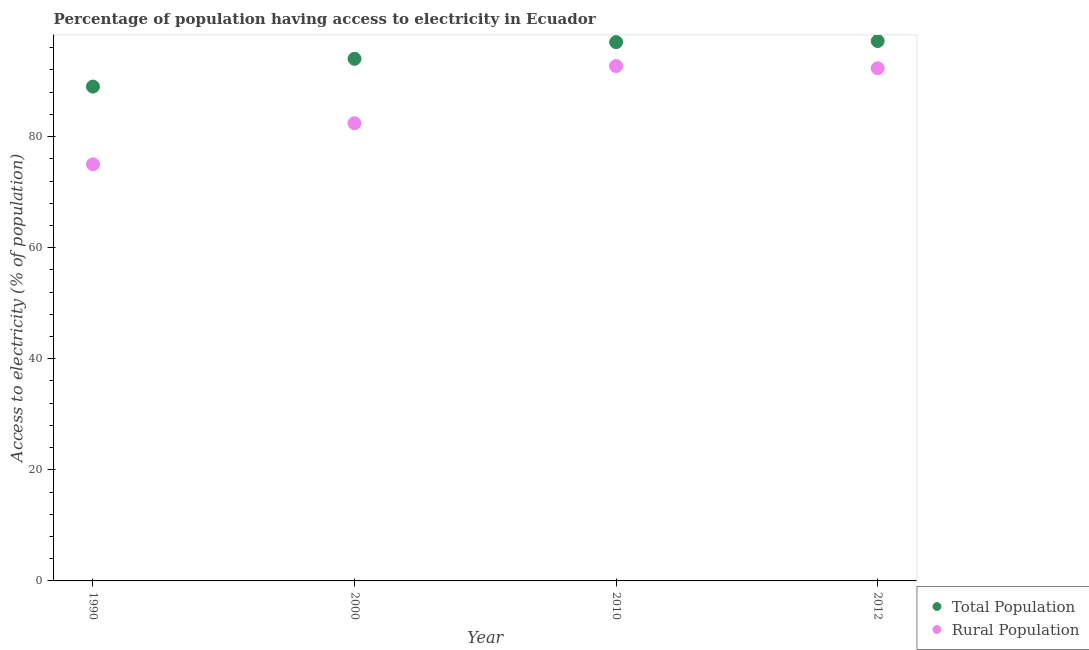Is the number of dotlines equal to the number of legend labels?
Ensure brevity in your answer.  Yes. What is the percentage of population having access to electricity in 2010?
Keep it short and to the point. 97. Across all years, what is the maximum percentage of population having access to electricity?
Give a very brief answer. 97.2. Across all years, what is the minimum percentage of rural population having access to electricity?
Provide a succinct answer. 75. In which year was the percentage of population having access to electricity minimum?
Offer a very short reply. 1990. What is the total percentage of population having access to electricity in the graph?
Keep it short and to the point. 377.2. What is the difference between the percentage of rural population having access to electricity in 2000 and that in 2012?
Keep it short and to the point. -9.9. What is the difference between the percentage of rural population having access to electricity in 2010 and the percentage of population having access to electricity in 2000?
Your response must be concise. -1.3. What is the average percentage of rural population having access to electricity per year?
Your answer should be compact. 85.6. In the year 1990, what is the difference between the percentage of rural population having access to electricity and percentage of population having access to electricity?
Ensure brevity in your answer.  -14. What is the ratio of the percentage of population having access to electricity in 2000 to that in 2012?
Provide a short and direct response. 0.97. Is the percentage of population having access to electricity in 2000 less than that in 2012?
Offer a very short reply. Yes. Is the difference between the percentage of population having access to electricity in 1990 and 2012 greater than the difference between the percentage of rural population having access to electricity in 1990 and 2012?
Your answer should be very brief. Yes. What is the difference between the highest and the second highest percentage of population having access to electricity?
Your answer should be very brief. 0.2. What is the difference between the highest and the lowest percentage of population having access to electricity?
Make the answer very short. 8.2. In how many years, is the percentage of rural population having access to electricity greater than the average percentage of rural population having access to electricity taken over all years?
Ensure brevity in your answer.  2. How many dotlines are there?
Make the answer very short. 2. How many years are there in the graph?
Provide a short and direct response. 4. Are the values on the major ticks of Y-axis written in scientific E-notation?
Offer a very short reply. No. Does the graph contain grids?
Give a very brief answer. No. How are the legend labels stacked?
Provide a succinct answer. Vertical. What is the title of the graph?
Give a very brief answer. Percentage of population having access to electricity in Ecuador. What is the label or title of the Y-axis?
Provide a succinct answer. Access to electricity (% of population). What is the Access to electricity (% of population) of Total Population in 1990?
Your answer should be compact. 89. What is the Access to electricity (% of population) of Total Population in 2000?
Provide a succinct answer. 94. What is the Access to electricity (% of population) of Rural Population in 2000?
Offer a terse response. 82.4. What is the Access to electricity (% of population) of Total Population in 2010?
Provide a succinct answer. 97. What is the Access to electricity (% of population) of Rural Population in 2010?
Give a very brief answer. 92.7. What is the Access to electricity (% of population) of Total Population in 2012?
Your answer should be very brief. 97.2. What is the Access to electricity (% of population) of Rural Population in 2012?
Provide a succinct answer. 92.3. Across all years, what is the maximum Access to electricity (% of population) in Total Population?
Ensure brevity in your answer.  97.2. Across all years, what is the maximum Access to electricity (% of population) in Rural Population?
Provide a succinct answer. 92.7. Across all years, what is the minimum Access to electricity (% of population) of Total Population?
Provide a succinct answer. 89. Across all years, what is the minimum Access to electricity (% of population) in Rural Population?
Give a very brief answer. 75. What is the total Access to electricity (% of population) in Total Population in the graph?
Keep it short and to the point. 377.2. What is the total Access to electricity (% of population) of Rural Population in the graph?
Ensure brevity in your answer.  342.4. What is the difference between the Access to electricity (% of population) of Rural Population in 1990 and that in 2010?
Give a very brief answer. -17.7. What is the difference between the Access to electricity (% of population) of Rural Population in 1990 and that in 2012?
Give a very brief answer. -17.3. What is the difference between the Access to electricity (% of population) of Total Population in 2000 and that in 2012?
Your answer should be compact. -3.2. What is the difference between the Access to electricity (% of population) in Rural Population in 2000 and that in 2012?
Ensure brevity in your answer.  -9.9. What is the difference between the Access to electricity (% of population) of Total Population in 2010 and that in 2012?
Offer a terse response. -0.2. What is the difference between the Access to electricity (% of population) of Rural Population in 2010 and that in 2012?
Your answer should be compact. 0.4. What is the difference between the Access to electricity (% of population) of Total Population in 1990 and the Access to electricity (% of population) of Rural Population in 2000?
Your answer should be very brief. 6.6. What is the difference between the Access to electricity (% of population) of Total Population in 2000 and the Access to electricity (% of population) of Rural Population in 2012?
Offer a very short reply. 1.7. What is the difference between the Access to electricity (% of population) of Total Population in 2010 and the Access to electricity (% of population) of Rural Population in 2012?
Keep it short and to the point. 4.7. What is the average Access to electricity (% of population) of Total Population per year?
Your response must be concise. 94.3. What is the average Access to electricity (% of population) in Rural Population per year?
Make the answer very short. 85.6. In the year 2000, what is the difference between the Access to electricity (% of population) of Total Population and Access to electricity (% of population) of Rural Population?
Give a very brief answer. 11.6. In the year 2012, what is the difference between the Access to electricity (% of population) of Total Population and Access to electricity (% of population) of Rural Population?
Your answer should be very brief. 4.9. What is the ratio of the Access to electricity (% of population) of Total Population in 1990 to that in 2000?
Provide a short and direct response. 0.95. What is the ratio of the Access to electricity (% of population) of Rural Population in 1990 to that in 2000?
Make the answer very short. 0.91. What is the ratio of the Access to electricity (% of population) in Total Population in 1990 to that in 2010?
Your response must be concise. 0.92. What is the ratio of the Access to electricity (% of population) of Rural Population in 1990 to that in 2010?
Make the answer very short. 0.81. What is the ratio of the Access to electricity (% of population) in Total Population in 1990 to that in 2012?
Your answer should be very brief. 0.92. What is the ratio of the Access to electricity (% of population) in Rural Population in 1990 to that in 2012?
Offer a terse response. 0.81. What is the ratio of the Access to electricity (% of population) of Total Population in 2000 to that in 2010?
Keep it short and to the point. 0.97. What is the ratio of the Access to electricity (% of population) of Total Population in 2000 to that in 2012?
Provide a succinct answer. 0.97. What is the ratio of the Access to electricity (% of population) in Rural Population in 2000 to that in 2012?
Give a very brief answer. 0.89. What is the ratio of the Access to electricity (% of population) of Rural Population in 2010 to that in 2012?
Give a very brief answer. 1. What is the difference between the highest and the lowest Access to electricity (% of population) in Rural Population?
Offer a terse response. 17.7. 